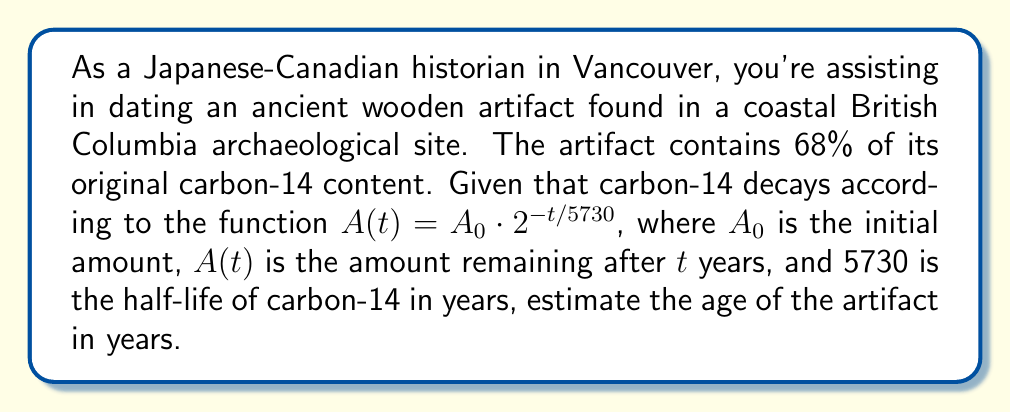Provide a solution to this math problem. To solve this problem, we'll use the logarithmic properties to isolate the variable $t$ in the decay function.

1) We start with the given decay function:
   $A(t) = A_0 \cdot 2^{-t/5730}$

2) We know that 68% of the original carbon-14 remains, so:
   $\frac{A(t)}{A_0} = 0.68$

3) Substituting this into our equation:
   $0.68 = 2^{-t/5730}$

4) To isolate $t$, we first take the natural log of both sides:
   $\ln(0.68) = \ln(2^{-t/5730})$

5) Using the logarithm property $\ln(a^b) = b\ln(a)$:
   $\ln(0.68) = -\frac{t}{5730} \ln(2)$

6) Multiply both sides by -5730:
   $-5730 \ln(0.68) = t \ln(2)$

7) Divide both sides by $\ln(2)$:
   $t = \frac{-5730 \ln(0.68)}{\ln(2)}$

8) Calculate the result:
   $t \approx 3242.76$ years

Therefore, the artifact is estimated to be about 3,243 years old.
Answer: The estimated age of the artifact is approximately 3,243 years. 